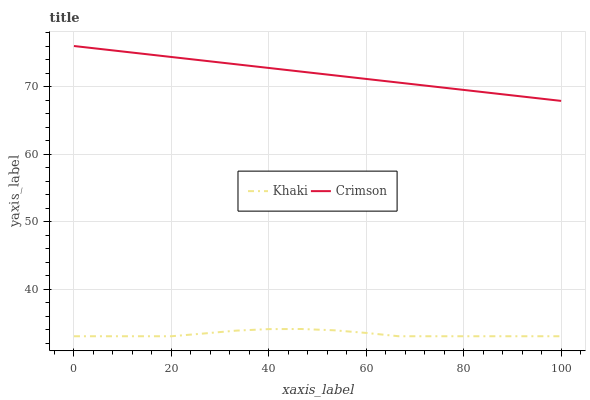Does Khaki have the minimum area under the curve?
Answer yes or no. Yes. Does Crimson have the maximum area under the curve?
Answer yes or no. Yes. Does Khaki have the maximum area under the curve?
Answer yes or no. No. Is Crimson the smoothest?
Answer yes or no. Yes. Is Khaki the roughest?
Answer yes or no. Yes. Is Khaki the smoothest?
Answer yes or no. No. Does Khaki have the lowest value?
Answer yes or no. Yes. Does Crimson have the highest value?
Answer yes or no. Yes. Does Khaki have the highest value?
Answer yes or no. No. Is Khaki less than Crimson?
Answer yes or no. Yes. Is Crimson greater than Khaki?
Answer yes or no. Yes. Does Khaki intersect Crimson?
Answer yes or no. No. 